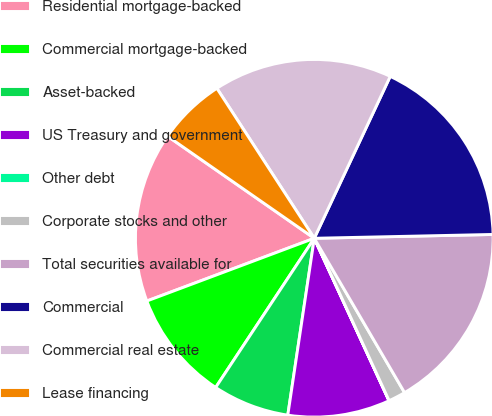Convert chart to OTSL. <chart><loc_0><loc_0><loc_500><loc_500><pie_chart><fcel>Residential mortgage-backed<fcel>Commercial mortgage-backed<fcel>Asset-backed<fcel>US Treasury and government<fcel>Other debt<fcel>Corporate stocks and other<fcel>Total securities available for<fcel>Commercial<fcel>Commercial real estate<fcel>Lease financing<nl><fcel>15.38%<fcel>10.0%<fcel>6.93%<fcel>9.23%<fcel>0.01%<fcel>1.55%<fcel>16.92%<fcel>17.68%<fcel>16.15%<fcel>6.16%<nl></chart> 